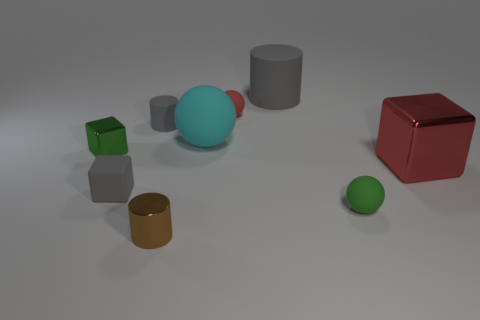What lighting conditions are hinted at by the shadows in the image? The shadows suggest a light source above and to the left of the objects, casting shadows diagonally across the surface. 